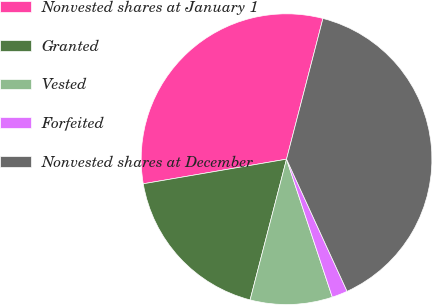Convert chart. <chart><loc_0><loc_0><loc_500><loc_500><pie_chart><fcel>Nonvested shares at January 1<fcel>Granted<fcel>Vested<fcel>Forfeited<fcel>Nonvested shares at December<nl><fcel>31.74%<fcel>18.26%<fcel>9.13%<fcel>1.74%<fcel>39.13%<nl></chart> 